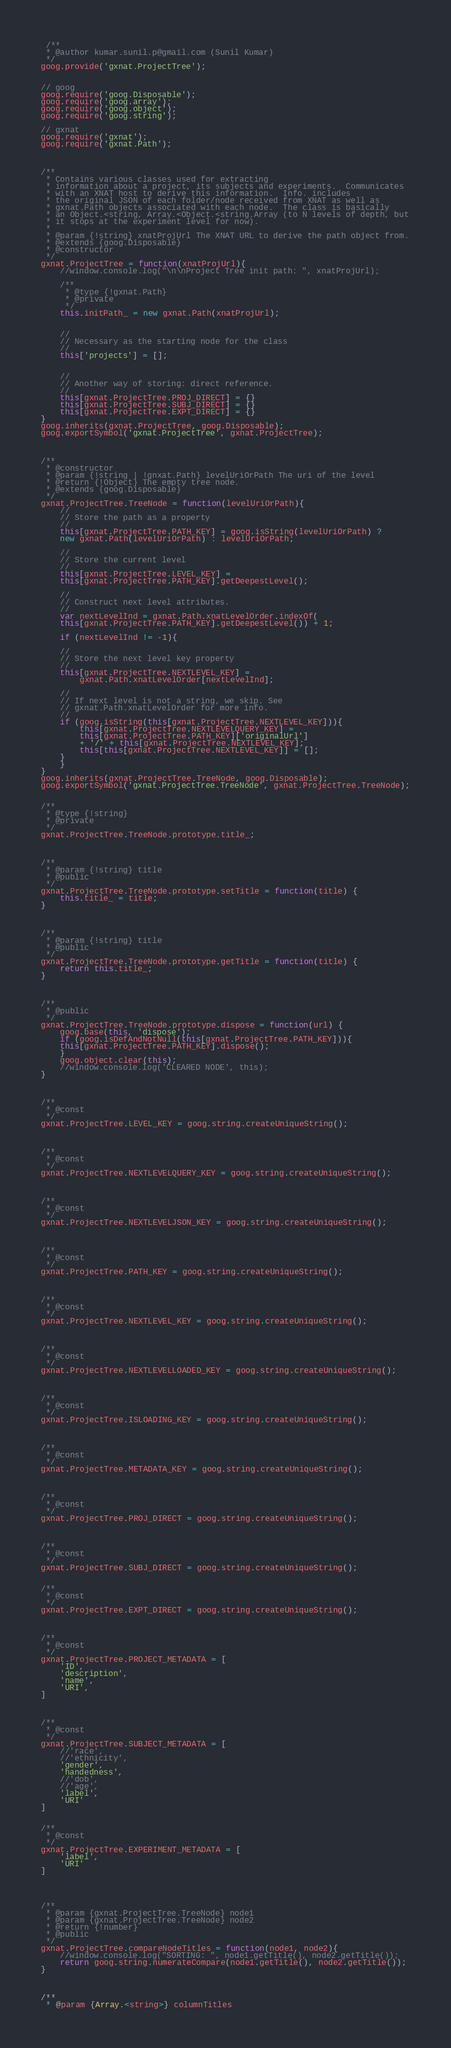<code> <loc_0><loc_0><loc_500><loc_500><_JavaScript_> /**
 * @author kumar.sunil.p@gmail.com (Sunil Kumar)
 */
goog.provide('gxnat.ProjectTree');


// goog
goog.require('goog.Disposable');
goog.require('goog.array');
goog.require('goog.object');
goog.require('goog.string');

// gxnat
goog.require('gxnat');
goog.require('gxnat.Path');



/**
 * Contains various classes used for extracting 
 * information about a project, its subjects and experiments.  Communicates
 * with an XNAT host to derive this information.  Info. includes
 * the original JSON of each folder/node received from XNAT as well as 
 * gxnat.Path objects associated with each node.  The class is basically
 * an Object.<string, Array.<Object.<string.Array (to N levels of depth, but
 * it stops at the experiment level for now).
 *
 * @param {!string} xnatProjUrl The XNAT URL to derive the path object from.
 * @extends {goog.Disposable}
 * @constructor
 */
gxnat.ProjectTree = function(xnatProjUrl){
    //window.console.log("\n\nProject Tree init path: ", xnatProjUrl);

    /**
     * @type {!gxnat.Path}
     * @private
     */
    this.initPath_ = new gxnat.Path(xnatProjUrl);


    //
    // Necessary as the starting node for the class
    //
    this['projects'] = [];


    //
    // Another way of storing: direct reference.
    //
    this[gxnat.ProjectTree.PROJ_DIRECT] = {}		 
    this[gxnat.ProjectTree.SUBJ_DIRECT] = {}		 
    this[gxnat.ProjectTree.EXPT_DIRECT] = {}		 
}
goog.inherits(gxnat.ProjectTree, goog.Disposable);
goog.exportSymbol('gxnat.ProjectTree', gxnat.ProjectTree);



/**
 * @constructor
 * @param {!string | !gnxat.Path} levelUriOrPath The uri of the level 
 * @return {!Object} The empty tree node.
 * @extends {goog.Disposable}
 */
gxnat.ProjectTree.TreeNode = function(levelUriOrPath){
    //
    // Store the path as a property
    //
    this[gxnat.ProjectTree.PATH_KEY] = goog.isString(levelUriOrPath) ? 
	new gxnat.Path(levelUriOrPath) : levelUriOrPath;
    
    //
    // Store the current level
    //
    this[gxnat.ProjectTree.LEVEL_KEY] = 
	this[gxnat.ProjectTree.PATH_KEY].getDeepestLevel();  

    //
    // Construct next level attributes.
    //
    var nextLevelInd = gxnat.Path.xnatLevelOrder.indexOf(
	this[gxnat.ProjectTree.PATH_KEY].getDeepestLevel()) + 1;

    if (nextLevelInd != -1){

	//
	// Store the next level key property
	//
	this[gxnat.ProjectTree.NEXTLEVEL_KEY] = 
	    gxnat.Path.xnatLevelOrder[nextLevelInd];

	//
	// If next level is not a string, we skip. See 
	// gxnat.Path.xnatLevelOrder for more info.
	//
	if (goog.isString(this[gxnat.ProjectTree.NEXTLEVEL_KEY])){
	    this[gxnat.ProjectTree.NEXTLEVELQUERY_KEY] = 
		this[gxnat.ProjectTree.PATH_KEY]['originalUrl'] 
		+ '/' + this[gxnat.ProjectTree.NEXTLEVEL_KEY];
	    this[this[gxnat.ProjectTree.NEXTLEVEL_KEY]] = [];
	}
    }
}
goog.inherits(gxnat.ProjectTree.TreeNode, goog.Disposable);
goog.exportSymbol('gxnat.ProjectTree.TreeNode', gxnat.ProjectTree.TreeNode);


/**
 * @type {!string}
 * @private
 */
gxnat.ProjectTree.TreeNode.prototype.title_;



/**
 * @param {!string} title
 * @public
 */
gxnat.ProjectTree.TreeNode.prototype.setTitle = function(title) {
    this.title_ = title;
}



/**
 * @param {!string} title
 * @public
 */
gxnat.ProjectTree.TreeNode.prototype.getTitle = function(title) {
    return this.title_;
}



/**
 * @public
 */
gxnat.ProjectTree.TreeNode.prototype.dispose = function(url) {
    goog.base(this, 'dispose');
    if (goog.isDefAndNotNull(this[gxnat.ProjectTree.PATH_KEY])){
	this[gxnat.ProjectTree.PATH_KEY].dispose();
    }
    goog.object.clear(this);
    //window.console.log('CLEARED NODE', this);
}



/**
 * @const
 */
gxnat.ProjectTree.LEVEL_KEY = goog.string.createUniqueString();



/**
 * @const
 */
gxnat.ProjectTree.NEXTLEVELQUERY_KEY = goog.string.createUniqueString();



/**
 * @const
 */
gxnat.ProjectTree.NEXTLEVELJSON_KEY = goog.string.createUniqueString();



/**
 * @const
 */
gxnat.ProjectTree.PATH_KEY = goog.string.createUniqueString();



/**
 * @const
 */
gxnat.ProjectTree.NEXTLEVEL_KEY = goog.string.createUniqueString();



/**
 * @const
 */
gxnat.ProjectTree.NEXTLEVELLOADED_KEY = goog.string.createUniqueString();



/**
 * @const
 */
gxnat.ProjectTree.ISLOADING_KEY = goog.string.createUniqueString();



/**
 * @const
 */
gxnat.ProjectTree.METADATA_KEY = goog.string.createUniqueString();



/**
 * @const
 */
gxnat.ProjectTree.PROJ_DIRECT = goog.string.createUniqueString();



/**
 * @const
 */
gxnat.ProjectTree.SUBJ_DIRECT = goog.string.createUniqueString();


/**
 * @const
 */
gxnat.ProjectTree.EXPT_DIRECT = goog.string.createUniqueString();



/**
 * @const
 */
gxnat.ProjectTree.PROJECT_METADATA = [
    'ID',
    'description',
    'name',
    'URI',
]



/**
 * @const
 */
gxnat.ProjectTree.SUBJECT_METADATA = [
    //'race',
    //'ethnicity',
    'gender',
    'handedness',
    //'dob',
    //'age',
    'label',
    'URI'
]


/**
 * @const
 */
gxnat.ProjectTree.EXPERIMENT_METADATA = [
    'label',
    'URI'
]




/**
 * @param {gxnat.ProjectTree.TreeNode} node1
 * @param {gxnat.ProjectTree.TreeNode} node2
 * @return {!number}
 * @public
 */
gxnat.ProjectTree.compareNodeTitles = function(node1, node2){
    //window.console.log("SORTING: ", node1.getTitle(), node2.getTitle());
    return goog.string.numerateCompare(node1.getTitle(), node2.getTitle());
}



/**
 * @param {Array.<string>} columnTitles</code> 